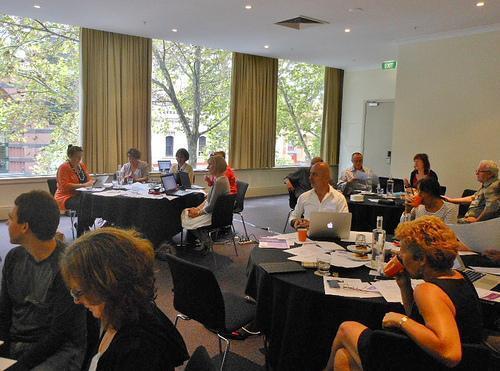How many computers are there?
Give a very brief answer. 6. How many people are drinking?
Give a very brief answer. 2. How many people are drinking from their cup?
Give a very brief answer. 2. 